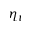Convert formula to latex. <formula><loc_0><loc_0><loc_500><loc_500>\eta _ { t }</formula> 